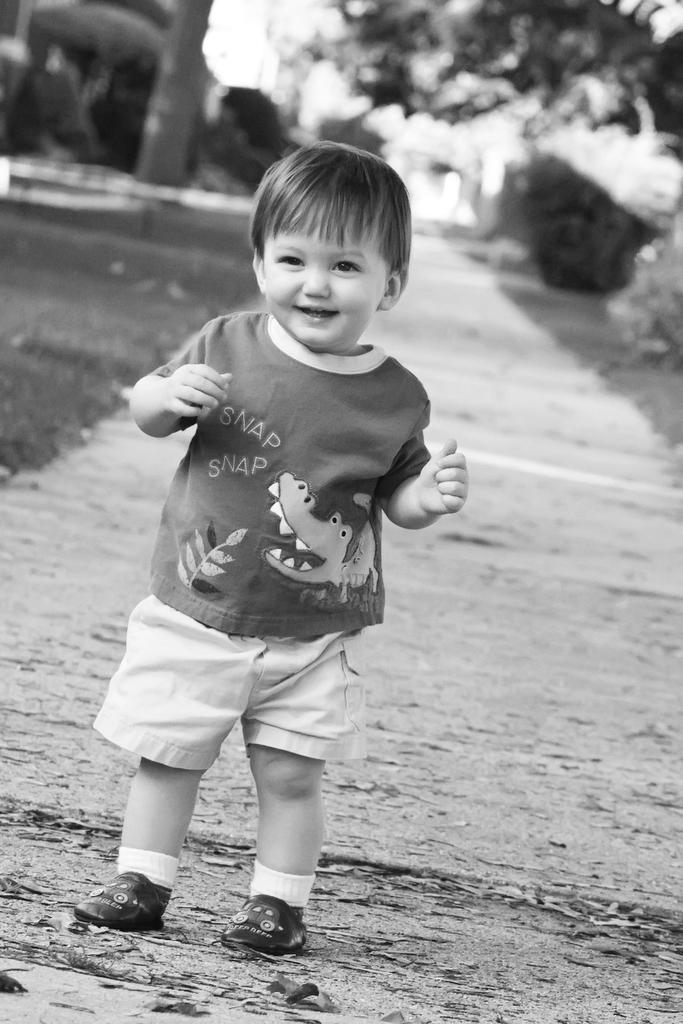What is the color scheme of the image? The image is black and white. Who is present in the image? There is a boy in the image. What is the boy doing in the image? The boy is standing on the ground and smiling. What type of natural environment is visible in the image? There are trees and grass in the image. How many dogs are present in the image? There are no dogs present in the image. What type of ear is visible on the boy in the image? The image is black and white, and there is no visible detail of the boy's ear. 